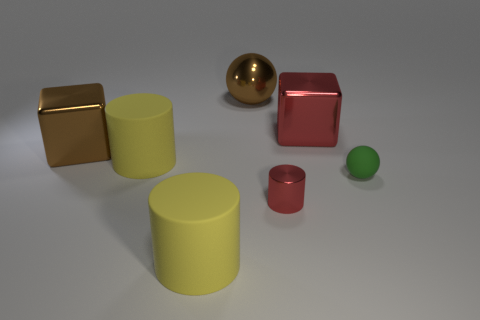Subtract all blue blocks. How many yellow cylinders are left? 2 Subtract all tiny metal cylinders. How many cylinders are left? 2 Add 2 metal spheres. How many objects exist? 9 Subtract 1 cylinders. How many cylinders are left? 2 Subtract all balls. How many objects are left? 5 Subtract all red blocks. Subtract all brown balls. How many blocks are left? 1 Subtract all blue cylinders. Subtract all big red objects. How many objects are left? 6 Add 4 tiny red metal cylinders. How many tiny red metal cylinders are left? 5 Add 1 large red blocks. How many large red blocks exist? 2 Subtract 1 green spheres. How many objects are left? 6 